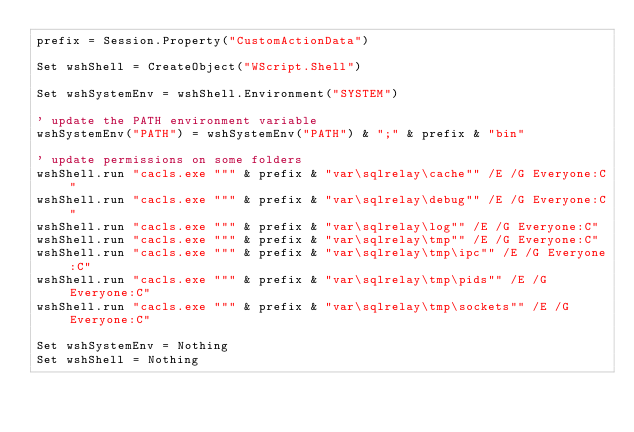<code> <loc_0><loc_0><loc_500><loc_500><_VisualBasic_>prefix = Session.Property("CustomActionData")

Set wshShell = CreateObject("WScript.Shell")

Set wshSystemEnv = wshShell.Environment("SYSTEM")

' update the PATH environment variable
wshSystemEnv("PATH") = wshSystemEnv("PATH") & ";" & prefix & "bin"

' update permissions on some folders
wshShell.run "cacls.exe """ & prefix & "var\sqlrelay\cache"" /E /G Everyone:C"
wshShell.run "cacls.exe """ & prefix & "var\sqlrelay\debug"" /E /G Everyone:C"
wshShell.run "cacls.exe """ & prefix & "var\sqlrelay\log"" /E /G Everyone:C"
wshShell.run "cacls.exe """ & prefix & "var\sqlrelay\tmp"" /E /G Everyone:C"
wshShell.run "cacls.exe """ & prefix & "var\sqlrelay\tmp\ipc"" /E /G Everyone:C"
wshShell.run "cacls.exe """ & prefix & "var\sqlrelay\tmp\pids"" /E /G Everyone:C"
wshShell.run "cacls.exe """ & prefix & "var\sqlrelay\tmp\sockets"" /E /G Everyone:C"

Set wshSystemEnv = Nothing
Set wshShell = Nothing
</code> 